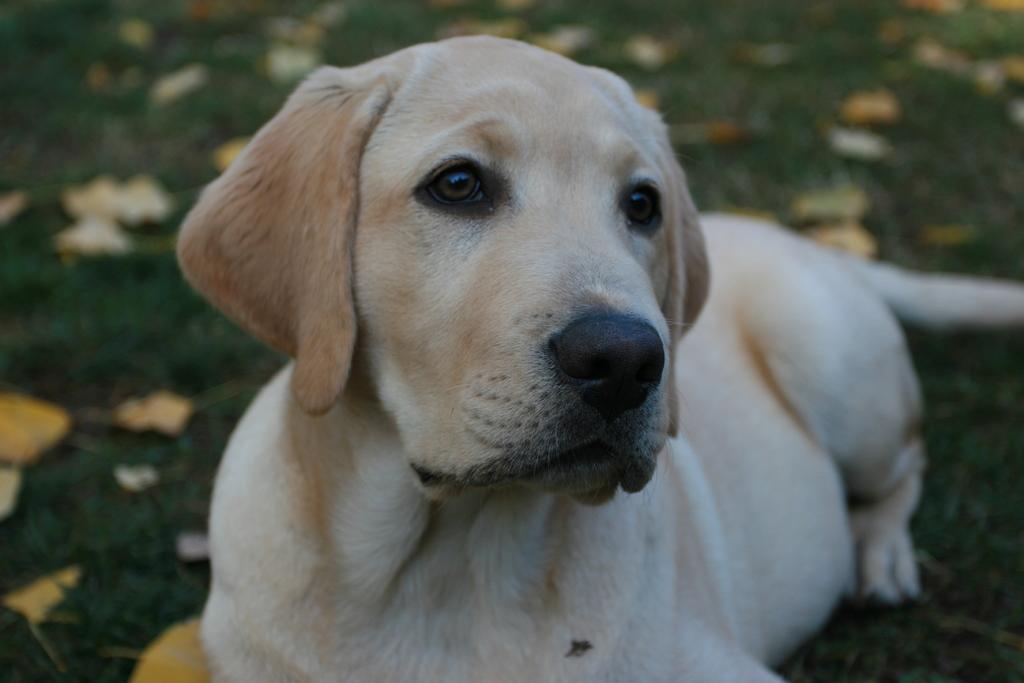How would you summarize this image in a sentence or two? In this image we can see a dog sitting on the ground, also we can see some leaves, and the background is blurred. 